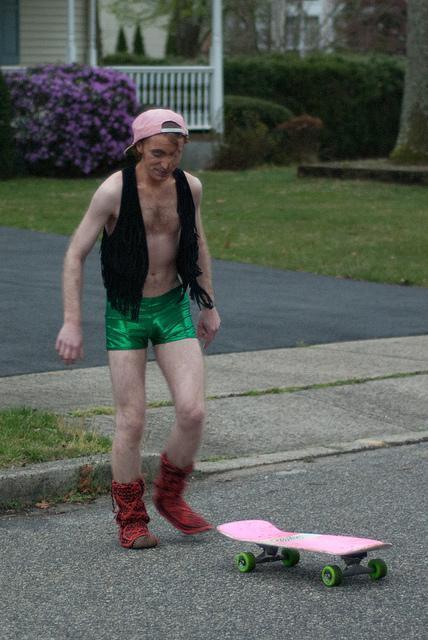How many men are wearing shirts?
Give a very brief answer. 0. How many elephants are there?
Give a very brief answer. 0. 